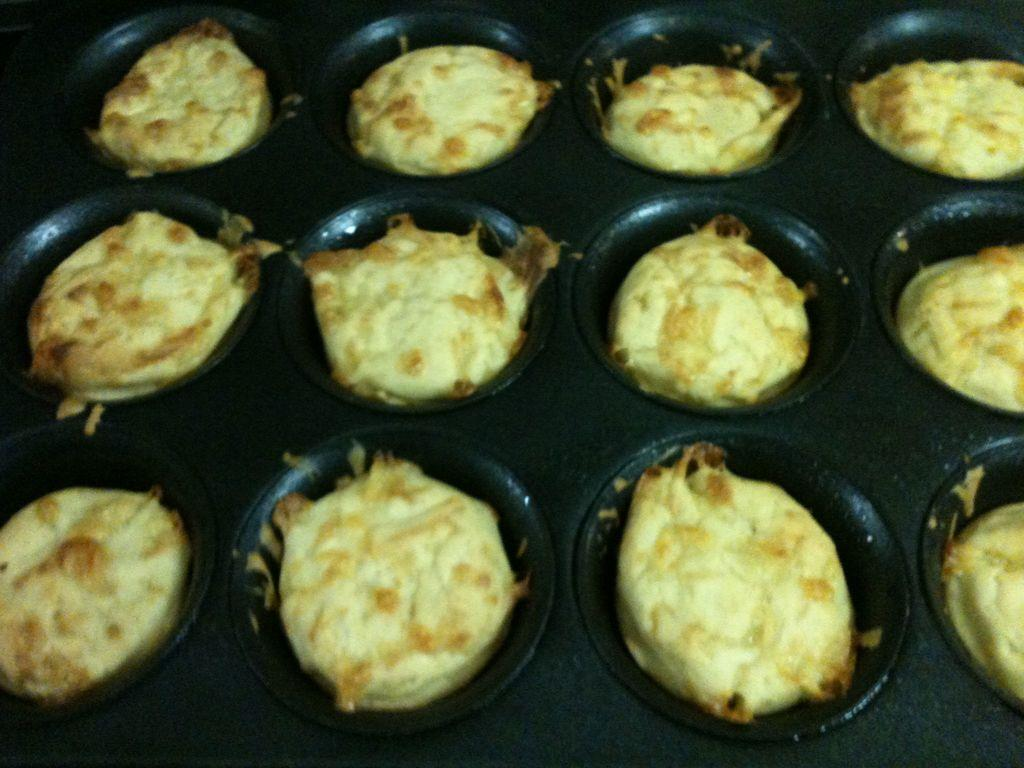What is present on the tray in the image? There are food items on the tray in the image. Can you describe the tray itself? The facts provided do not give specific details about the tray, but we know it is present in the image. What is the reaction of the unit to the color in the image? There is no unit or color mentioned in the image, so it is not possible to answer this question. 